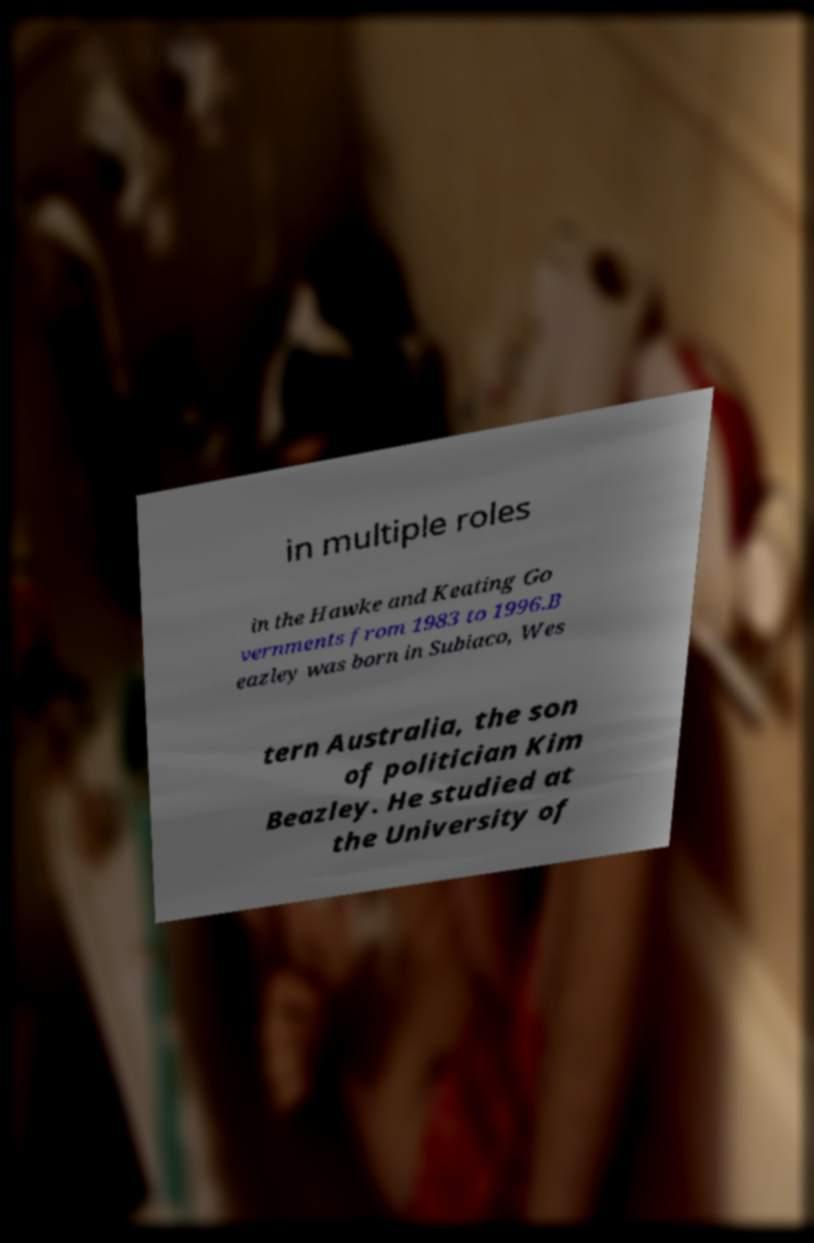Please identify and transcribe the text found in this image. in multiple roles in the Hawke and Keating Go vernments from 1983 to 1996.B eazley was born in Subiaco, Wes tern Australia, the son of politician Kim Beazley. He studied at the University of 